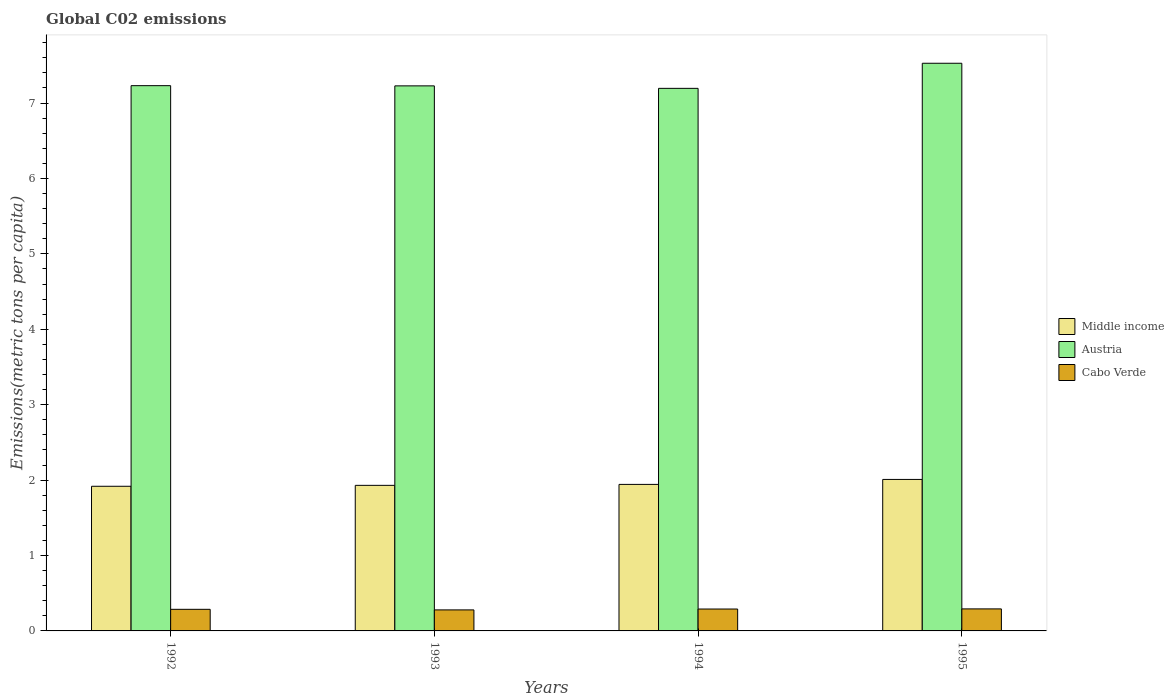How many groups of bars are there?
Keep it short and to the point. 4. Are the number of bars on each tick of the X-axis equal?
Give a very brief answer. Yes. How many bars are there on the 2nd tick from the right?
Provide a succinct answer. 3. What is the label of the 3rd group of bars from the left?
Offer a terse response. 1994. What is the amount of CO2 emitted in in Austria in 1993?
Give a very brief answer. 7.23. Across all years, what is the maximum amount of CO2 emitted in in Middle income?
Give a very brief answer. 2.01. Across all years, what is the minimum amount of CO2 emitted in in Cabo Verde?
Ensure brevity in your answer.  0.28. In which year was the amount of CO2 emitted in in Middle income maximum?
Offer a terse response. 1995. What is the total amount of CO2 emitted in in Middle income in the graph?
Offer a terse response. 7.8. What is the difference between the amount of CO2 emitted in in Middle income in 1994 and that in 1995?
Your answer should be very brief. -0.07. What is the difference between the amount of CO2 emitted in in Middle income in 1992 and the amount of CO2 emitted in in Austria in 1994?
Ensure brevity in your answer.  -5.28. What is the average amount of CO2 emitted in in Austria per year?
Provide a succinct answer. 7.29. In the year 1993, what is the difference between the amount of CO2 emitted in in Cabo Verde and amount of CO2 emitted in in Middle income?
Make the answer very short. -1.65. In how many years, is the amount of CO2 emitted in in Middle income greater than 2 metric tons per capita?
Offer a very short reply. 1. What is the ratio of the amount of CO2 emitted in in Austria in 1992 to that in 1995?
Your answer should be compact. 0.96. Is the amount of CO2 emitted in in Cabo Verde in 1993 less than that in 1994?
Ensure brevity in your answer.  Yes. What is the difference between the highest and the second highest amount of CO2 emitted in in Middle income?
Provide a short and direct response. 0.07. What is the difference between the highest and the lowest amount of CO2 emitted in in Middle income?
Your response must be concise. 0.09. In how many years, is the amount of CO2 emitted in in Cabo Verde greater than the average amount of CO2 emitted in in Cabo Verde taken over all years?
Your response must be concise. 2. What does the 3rd bar from the left in 1994 represents?
Keep it short and to the point. Cabo Verde. How many years are there in the graph?
Keep it short and to the point. 4. Are the values on the major ticks of Y-axis written in scientific E-notation?
Provide a short and direct response. No. Does the graph contain any zero values?
Ensure brevity in your answer.  No. How are the legend labels stacked?
Provide a short and direct response. Vertical. What is the title of the graph?
Provide a succinct answer. Global C02 emissions. Does "San Marino" appear as one of the legend labels in the graph?
Ensure brevity in your answer.  No. What is the label or title of the Y-axis?
Offer a very short reply. Emissions(metric tons per capita). What is the Emissions(metric tons per capita) in Middle income in 1992?
Your response must be concise. 1.92. What is the Emissions(metric tons per capita) of Austria in 1992?
Provide a short and direct response. 7.23. What is the Emissions(metric tons per capita) of Cabo Verde in 1992?
Keep it short and to the point. 0.29. What is the Emissions(metric tons per capita) of Middle income in 1993?
Provide a succinct answer. 1.93. What is the Emissions(metric tons per capita) in Austria in 1993?
Keep it short and to the point. 7.23. What is the Emissions(metric tons per capita) of Cabo Verde in 1993?
Give a very brief answer. 0.28. What is the Emissions(metric tons per capita) of Middle income in 1994?
Make the answer very short. 1.94. What is the Emissions(metric tons per capita) in Austria in 1994?
Your answer should be compact. 7.19. What is the Emissions(metric tons per capita) in Cabo Verde in 1994?
Your response must be concise. 0.29. What is the Emissions(metric tons per capita) of Middle income in 1995?
Your response must be concise. 2.01. What is the Emissions(metric tons per capita) in Austria in 1995?
Your answer should be compact. 7.53. What is the Emissions(metric tons per capita) of Cabo Verde in 1995?
Provide a short and direct response. 0.29. Across all years, what is the maximum Emissions(metric tons per capita) of Middle income?
Offer a very short reply. 2.01. Across all years, what is the maximum Emissions(metric tons per capita) of Austria?
Your response must be concise. 7.53. Across all years, what is the maximum Emissions(metric tons per capita) in Cabo Verde?
Your answer should be compact. 0.29. Across all years, what is the minimum Emissions(metric tons per capita) of Middle income?
Offer a very short reply. 1.92. Across all years, what is the minimum Emissions(metric tons per capita) of Austria?
Provide a short and direct response. 7.19. Across all years, what is the minimum Emissions(metric tons per capita) of Cabo Verde?
Offer a terse response. 0.28. What is the total Emissions(metric tons per capita) in Middle income in the graph?
Your answer should be compact. 7.8. What is the total Emissions(metric tons per capita) of Austria in the graph?
Provide a succinct answer. 29.18. What is the total Emissions(metric tons per capita) of Cabo Verde in the graph?
Provide a succinct answer. 1.15. What is the difference between the Emissions(metric tons per capita) of Middle income in 1992 and that in 1993?
Keep it short and to the point. -0.01. What is the difference between the Emissions(metric tons per capita) in Austria in 1992 and that in 1993?
Offer a very short reply. 0. What is the difference between the Emissions(metric tons per capita) in Cabo Verde in 1992 and that in 1993?
Provide a short and direct response. 0.01. What is the difference between the Emissions(metric tons per capita) of Middle income in 1992 and that in 1994?
Make the answer very short. -0.02. What is the difference between the Emissions(metric tons per capita) in Austria in 1992 and that in 1994?
Make the answer very short. 0.04. What is the difference between the Emissions(metric tons per capita) in Cabo Verde in 1992 and that in 1994?
Ensure brevity in your answer.  -0. What is the difference between the Emissions(metric tons per capita) in Middle income in 1992 and that in 1995?
Keep it short and to the point. -0.09. What is the difference between the Emissions(metric tons per capita) of Austria in 1992 and that in 1995?
Offer a terse response. -0.3. What is the difference between the Emissions(metric tons per capita) in Cabo Verde in 1992 and that in 1995?
Make the answer very short. -0.01. What is the difference between the Emissions(metric tons per capita) in Middle income in 1993 and that in 1994?
Provide a succinct answer. -0.01. What is the difference between the Emissions(metric tons per capita) in Austria in 1993 and that in 1994?
Your answer should be very brief. 0.03. What is the difference between the Emissions(metric tons per capita) of Cabo Verde in 1993 and that in 1994?
Give a very brief answer. -0.01. What is the difference between the Emissions(metric tons per capita) of Middle income in 1993 and that in 1995?
Offer a terse response. -0.08. What is the difference between the Emissions(metric tons per capita) in Austria in 1993 and that in 1995?
Offer a terse response. -0.3. What is the difference between the Emissions(metric tons per capita) in Cabo Verde in 1993 and that in 1995?
Offer a very short reply. -0.01. What is the difference between the Emissions(metric tons per capita) of Middle income in 1994 and that in 1995?
Keep it short and to the point. -0.07. What is the difference between the Emissions(metric tons per capita) in Austria in 1994 and that in 1995?
Provide a short and direct response. -0.33. What is the difference between the Emissions(metric tons per capita) in Cabo Verde in 1994 and that in 1995?
Provide a short and direct response. -0. What is the difference between the Emissions(metric tons per capita) of Middle income in 1992 and the Emissions(metric tons per capita) of Austria in 1993?
Make the answer very short. -5.31. What is the difference between the Emissions(metric tons per capita) of Middle income in 1992 and the Emissions(metric tons per capita) of Cabo Verde in 1993?
Your response must be concise. 1.64. What is the difference between the Emissions(metric tons per capita) of Austria in 1992 and the Emissions(metric tons per capita) of Cabo Verde in 1993?
Provide a succinct answer. 6.95. What is the difference between the Emissions(metric tons per capita) of Middle income in 1992 and the Emissions(metric tons per capita) of Austria in 1994?
Your response must be concise. -5.28. What is the difference between the Emissions(metric tons per capita) in Middle income in 1992 and the Emissions(metric tons per capita) in Cabo Verde in 1994?
Your answer should be very brief. 1.63. What is the difference between the Emissions(metric tons per capita) of Austria in 1992 and the Emissions(metric tons per capita) of Cabo Verde in 1994?
Provide a short and direct response. 6.94. What is the difference between the Emissions(metric tons per capita) of Middle income in 1992 and the Emissions(metric tons per capita) of Austria in 1995?
Ensure brevity in your answer.  -5.61. What is the difference between the Emissions(metric tons per capita) in Middle income in 1992 and the Emissions(metric tons per capita) in Cabo Verde in 1995?
Your response must be concise. 1.63. What is the difference between the Emissions(metric tons per capita) in Austria in 1992 and the Emissions(metric tons per capita) in Cabo Verde in 1995?
Offer a terse response. 6.94. What is the difference between the Emissions(metric tons per capita) of Middle income in 1993 and the Emissions(metric tons per capita) of Austria in 1994?
Provide a short and direct response. -5.26. What is the difference between the Emissions(metric tons per capita) in Middle income in 1993 and the Emissions(metric tons per capita) in Cabo Verde in 1994?
Offer a very short reply. 1.64. What is the difference between the Emissions(metric tons per capita) in Austria in 1993 and the Emissions(metric tons per capita) in Cabo Verde in 1994?
Your response must be concise. 6.94. What is the difference between the Emissions(metric tons per capita) of Middle income in 1993 and the Emissions(metric tons per capita) of Austria in 1995?
Provide a succinct answer. -5.6. What is the difference between the Emissions(metric tons per capita) in Middle income in 1993 and the Emissions(metric tons per capita) in Cabo Verde in 1995?
Provide a succinct answer. 1.64. What is the difference between the Emissions(metric tons per capita) in Austria in 1993 and the Emissions(metric tons per capita) in Cabo Verde in 1995?
Provide a short and direct response. 6.94. What is the difference between the Emissions(metric tons per capita) in Middle income in 1994 and the Emissions(metric tons per capita) in Austria in 1995?
Make the answer very short. -5.58. What is the difference between the Emissions(metric tons per capita) in Middle income in 1994 and the Emissions(metric tons per capita) in Cabo Verde in 1995?
Offer a terse response. 1.65. What is the difference between the Emissions(metric tons per capita) in Austria in 1994 and the Emissions(metric tons per capita) in Cabo Verde in 1995?
Your answer should be very brief. 6.9. What is the average Emissions(metric tons per capita) of Middle income per year?
Offer a very short reply. 1.95. What is the average Emissions(metric tons per capita) of Austria per year?
Offer a very short reply. 7.29. What is the average Emissions(metric tons per capita) in Cabo Verde per year?
Offer a very short reply. 0.29. In the year 1992, what is the difference between the Emissions(metric tons per capita) in Middle income and Emissions(metric tons per capita) in Austria?
Your answer should be compact. -5.31. In the year 1992, what is the difference between the Emissions(metric tons per capita) in Middle income and Emissions(metric tons per capita) in Cabo Verde?
Ensure brevity in your answer.  1.63. In the year 1992, what is the difference between the Emissions(metric tons per capita) of Austria and Emissions(metric tons per capita) of Cabo Verde?
Your answer should be very brief. 6.94. In the year 1993, what is the difference between the Emissions(metric tons per capita) in Middle income and Emissions(metric tons per capita) in Austria?
Make the answer very short. -5.3. In the year 1993, what is the difference between the Emissions(metric tons per capita) of Middle income and Emissions(metric tons per capita) of Cabo Verde?
Offer a very short reply. 1.65. In the year 1993, what is the difference between the Emissions(metric tons per capita) of Austria and Emissions(metric tons per capita) of Cabo Verde?
Your response must be concise. 6.95. In the year 1994, what is the difference between the Emissions(metric tons per capita) of Middle income and Emissions(metric tons per capita) of Austria?
Give a very brief answer. -5.25. In the year 1994, what is the difference between the Emissions(metric tons per capita) in Middle income and Emissions(metric tons per capita) in Cabo Verde?
Make the answer very short. 1.65. In the year 1994, what is the difference between the Emissions(metric tons per capita) in Austria and Emissions(metric tons per capita) in Cabo Verde?
Keep it short and to the point. 6.9. In the year 1995, what is the difference between the Emissions(metric tons per capita) of Middle income and Emissions(metric tons per capita) of Austria?
Provide a succinct answer. -5.52. In the year 1995, what is the difference between the Emissions(metric tons per capita) of Middle income and Emissions(metric tons per capita) of Cabo Verde?
Your answer should be compact. 1.72. In the year 1995, what is the difference between the Emissions(metric tons per capita) of Austria and Emissions(metric tons per capita) of Cabo Verde?
Keep it short and to the point. 7.23. What is the ratio of the Emissions(metric tons per capita) in Cabo Verde in 1992 to that in 1993?
Your answer should be very brief. 1.03. What is the ratio of the Emissions(metric tons per capita) of Middle income in 1992 to that in 1994?
Your answer should be very brief. 0.99. What is the ratio of the Emissions(metric tons per capita) of Cabo Verde in 1992 to that in 1994?
Give a very brief answer. 0.99. What is the ratio of the Emissions(metric tons per capita) of Middle income in 1992 to that in 1995?
Make the answer very short. 0.95. What is the ratio of the Emissions(metric tons per capita) of Austria in 1992 to that in 1995?
Ensure brevity in your answer.  0.96. What is the ratio of the Emissions(metric tons per capita) of Cabo Verde in 1992 to that in 1995?
Provide a short and direct response. 0.98. What is the ratio of the Emissions(metric tons per capita) of Austria in 1993 to that in 1994?
Your answer should be very brief. 1. What is the ratio of the Emissions(metric tons per capita) of Cabo Verde in 1993 to that in 1994?
Your response must be concise. 0.96. What is the ratio of the Emissions(metric tons per capita) in Austria in 1993 to that in 1995?
Offer a terse response. 0.96. What is the ratio of the Emissions(metric tons per capita) in Cabo Verde in 1993 to that in 1995?
Offer a terse response. 0.95. What is the ratio of the Emissions(metric tons per capita) in Middle income in 1994 to that in 1995?
Ensure brevity in your answer.  0.97. What is the ratio of the Emissions(metric tons per capita) of Austria in 1994 to that in 1995?
Offer a terse response. 0.96. What is the ratio of the Emissions(metric tons per capita) in Cabo Verde in 1994 to that in 1995?
Your answer should be very brief. 0.99. What is the difference between the highest and the second highest Emissions(metric tons per capita) in Middle income?
Provide a succinct answer. 0.07. What is the difference between the highest and the second highest Emissions(metric tons per capita) in Austria?
Provide a succinct answer. 0.3. What is the difference between the highest and the second highest Emissions(metric tons per capita) in Cabo Verde?
Your response must be concise. 0. What is the difference between the highest and the lowest Emissions(metric tons per capita) of Middle income?
Ensure brevity in your answer.  0.09. What is the difference between the highest and the lowest Emissions(metric tons per capita) in Austria?
Ensure brevity in your answer.  0.33. What is the difference between the highest and the lowest Emissions(metric tons per capita) of Cabo Verde?
Provide a short and direct response. 0.01. 